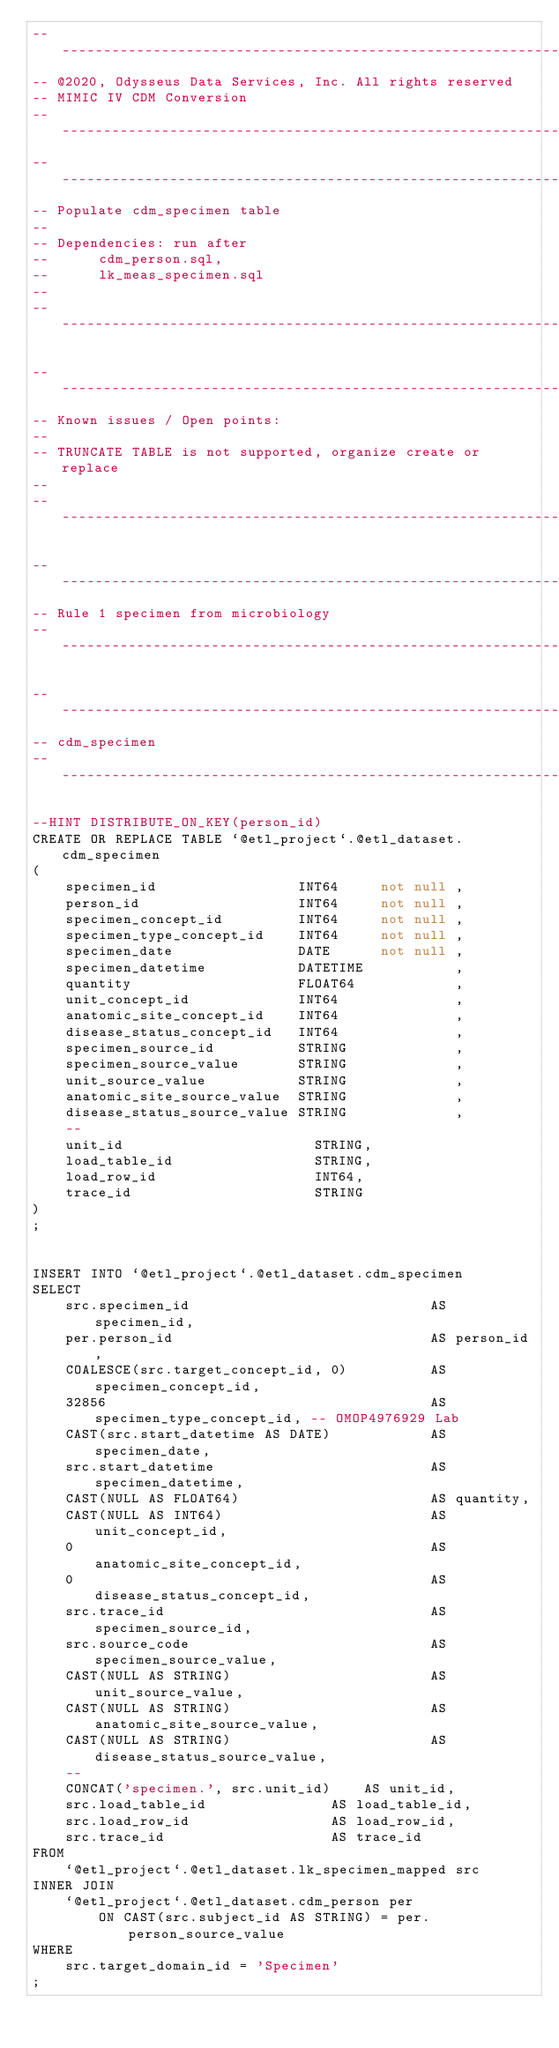<code> <loc_0><loc_0><loc_500><loc_500><_SQL_>-- -------------------------------------------------------------------
-- @2020, Odysseus Data Services, Inc. All rights reserved
-- MIMIC IV CDM Conversion
-- -------------------------------------------------------------------
-- -------------------------------------------------------------------
-- Populate cdm_specimen table
-- 
-- Dependencies: run after 
--      cdm_person.sql,
--      lk_meas_specimen.sql
--      
-- -------------------------------------------------------------------

-- -------------------------------------------------------------------
-- Known issues / Open points:
--
-- TRUNCATE TABLE is not supported, organize create or replace
--
-- -------------------------------------------------------------------

-- -------------------------------------------------------------------
-- Rule 1 specimen from microbiology
-- -------------------------------------------------------------------

-- -------------------------------------------------------------------
-- cdm_specimen
-- -------------------------------------------------------------------

--HINT DISTRIBUTE_ON_KEY(person_id)
CREATE OR REPLACE TABLE `@etl_project`.@etl_dataset.cdm_specimen
(
    specimen_id                 INT64     not null ,
    person_id                   INT64     not null ,
    specimen_concept_id         INT64     not null ,
    specimen_type_concept_id    INT64     not null ,
    specimen_date               DATE      not null ,
    specimen_datetime           DATETIME           ,
    quantity                    FLOAT64            ,
    unit_concept_id             INT64              ,
    anatomic_site_concept_id    INT64              ,
    disease_status_concept_id   INT64              ,
    specimen_source_id          STRING             ,
    specimen_source_value       STRING             ,
    unit_source_value           STRING             ,
    anatomic_site_source_value  STRING             ,
    disease_status_source_value STRING             ,
    -- 
    unit_id                       STRING,
    load_table_id                 STRING,
    load_row_id                   INT64,
    trace_id                      STRING
)
;


INSERT INTO `@etl_project`.@etl_dataset.cdm_specimen
SELECT
    src.specimen_id                             AS specimen_id,
    per.person_id                               AS person_id,
    COALESCE(src.target_concept_id, 0)          AS specimen_concept_id,
    32856                                       AS specimen_type_concept_id, -- OMOP4976929 Lab
    CAST(src.start_datetime AS DATE)            AS specimen_date,
    src.start_datetime                          AS specimen_datetime,
    CAST(NULL AS FLOAT64)                       AS quantity,
    CAST(NULL AS INT64)                         AS unit_concept_id,
    0                                           AS anatomic_site_concept_id,
    0                                           AS disease_status_concept_id,
    src.trace_id                                AS specimen_source_id,
    src.source_code                             AS specimen_source_value,
    CAST(NULL AS STRING)                        AS unit_source_value,
    CAST(NULL AS STRING)                        AS anatomic_site_source_value,
    CAST(NULL AS STRING)                        AS disease_status_source_value,
    -- 
    CONCAT('specimen.', src.unit_id)    AS unit_id,
    src.load_table_id               AS load_table_id,
    src.load_row_id                 AS load_row_id,
    src.trace_id                    AS trace_id
FROM
    `@etl_project`.@etl_dataset.lk_specimen_mapped src
INNER JOIN
    `@etl_project`.@etl_dataset.cdm_person per
        ON CAST(src.subject_id AS STRING) = per.person_source_value
WHERE
    src.target_domain_id = 'Specimen'
;
</code> 